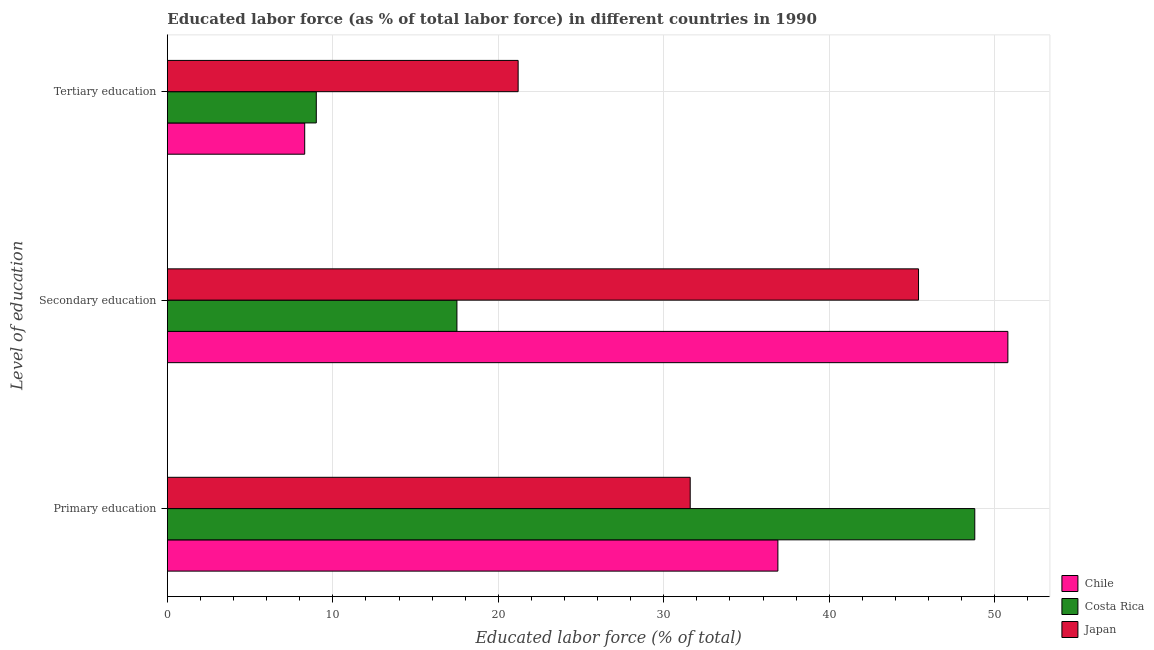How many bars are there on the 1st tick from the top?
Ensure brevity in your answer.  3. What is the percentage of labor force who received tertiary education in Japan?
Offer a terse response. 21.2. Across all countries, what is the maximum percentage of labor force who received secondary education?
Offer a very short reply. 50.8. In which country was the percentage of labor force who received primary education maximum?
Offer a terse response. Costa Rica. What is the total percentage of labor force who received secondary education in the graph?
Your answer should be very brief. 113.7. What is the difference between the percentage of labor force who received secondary education in Chile and that in Costa Rica?
Keep it short and to the point. 33.3. What is the difference between the percentage of labor force who received primary education in Chile and the percentage of labor force who received secondary education in Japan?
Ensure brevity in your answer.  -8.5. What is the average percentage of labor force who received tertiary education per country?
Provide a short and direct response. 12.83. What is the difference between the percentage of labor force who received secondary education and percentage of labor force who received primary education in Japan?
Your response must be concise. 13.8. In how many countries, is the percentage of labor force who received tertiary education greater than 44 %?
Your answer should be very brief. 0. What is the ratio of the percentage of labor force who received primary education in Chile to that in Japan?
Provide a succinct answer. 1.17. What is the difference between the highest and the second highest percentage of labor force who received tertiary education?
Your answer should be compact. 12.2. What is the difference between the highest and the lowest percentage of labor force who received primary education?
Your answer should be compact. 17.2. In how many countries, is the percentage of labor force who received tertiary education greater than the average percentage of labor force who received tertiary education taken over all countries?
Provide a short and direct response. 1. Is the sum of the percentage of labor force who received tertiary education in Costa Rica and Chile greater than the maximum percentage of labor force who received primary education across all countries?
Make the answer very short. No. What does the 3rd bar from the top in Secondary education represents?
Offer a very short reply. Chile. How many bars are there?
Your answer should be very brief. 9. Are the values on the major ticks of X-axis written in scientific E-notation?
Provide a succinct answer. No. Does the graph contain any zero values?
Make the answer very short. No. Does the graph contain grids?
Your answer should be very brief. Yes. Where does the legend appear in the graph?
Your answer should be very brief. Bottom right. What is the title of the graph?
Your answer should be very brief. Educated labor force (as % of total labor force) in different countries in 1990. Does "South Africa" appear as one of the legend labels in the graph?
Keep it short and to the point. No. What is the label or title of the X-axis?
Make the answer very short. Educated labor force (% of total). What is the label or title of the Y-axis?
Offer a terse response. Level of education. What is the Educated labor force (% of total) of Chile in Primary education?
Keep it short and to the point. 36.9. What is the Educated labor force (% of total) in Costa Rica in Primary education?
Give a very brief answer. 48.8. What is the Educated labor force (% of total) of Japan in Primary education?
Your response must be concise. 31.6. What is the Educated labor force (% of total) in Chile in Secondary education?
Provide a short and direct response. 50.8. What is the Educated labor force (% of total) in Costa Rica in Secondary education?
Ensure brevity in your answer.  17.5. What is the Educated labor force (% of total) in Japan in Secondary education?
Offer a very short reply. 45.4. What is the Educated labor force (% of total) of Chile in Tertiary education?
Make the answer very short. 8.3. What is the Educated labor force (% of total) in Costa Rica in Tertiary education?
Your response must be concise. 9. What is the Educated labor force (% of total) in Japan in Tertiary education?
Provide a short and direct response. 21.2. Across all Level of education, what is the maximum Educated labor force (% of total) in Chile?
Your answer should be compact. 50.8. Across all Level of education, what is the maximum Educated labor force (% of total) in Costa Rica?
Your response must be concise. 48.8. Across all Level of education, what is the maximum Educated labor force (% of total) of Japan?
Ensure brevity in your answer.  45.4. Across all Level of education, what is the minimum Educated labor force (% of total) of Chile?
Provide a short and direct response. 8.3. Across all Level of education, what is the minimum Educated labor force (% of total) of Costa Rica?
Your response must be concise. 9. Across all Level of education, what is the minimum Educated labor force (% of total) in Japan?
Your response must be concise. 21.2. What is the total Educated labor force (% of total) in Chile in the graph?
Ensure brevity in your answer.  96. What is the total Educated labor force (% of total) in Costa Rica in the graph?
Provide a succinct answer. 75.3. What is the total Educated labor force (% of total) of Japan in the graph?
Your answer should be compact. 98.2. What is the difference between the Educated labor force (% of total) in Chile in Primary education and that in Secondary education?
Your answer should be compact. -13.9. What is the difference between the Educated labor force (% of total) of Costa Rica in Primary education and that in Secondary education?
Your answer should be very brief. 31.3. What is the difference between the Educated labor force (% of total) of Chile in Primary education and that in Tertiary education?
Make the answer very short. 28.6. What is the difference between the Educated labor force (% of total) of Costa Rica in Primary education and that in Tertiary education?
Provide a short and direct response. 39.8. What is the difference between the Educated labor force (% of total) in Japan in Primary education and that in Tertiary education?
Keep it short and to the point. 10.4. What is the difference between the Educated labor force (% of total) of Chile in Secondary education and that in Tertiary education?
Offer a very short reply. 42.5. What is the difference between the Educated labor force (% of total) of Costa Rica in Secondary education and that in Tertiary education?
Your answer should be compact. 8.5. What is the difference between the Educated labor force (% of total) in Japan in Secondary education and that in Tertiary education?
Offer a terse response. 24.2. What is the difference between the Educated labor force (% of total) of Chile in Primary education and the Educated labor force (% of total) of Japan in Secondary education?
Provide a short and direct response. -8.5. What is the difference between the Educated labor force (% of total) in Costa Rica in Primary education and the Educated labor force (% of total) in Japan in Secondary education?
Your response must be concise. 3.4. What is the difference between the Educated labor force (% of total) in Chile in Primary education and the Educated labor force (% of total) in Costa Rica in Tertiary education?
Your response must be concise. 27.9. What is the difference between the Educated labor force (% of total) in Chile in Primary education and the Educated labor force (% of total) in Japan in Tertiary education?
Offer a terse response. 15.7. What is the difference between the Educated labor force (% of total) in Costa Rica in Primary education and the Educated labor force (% of total) in Japan in Tertiary education?
Give a very brief answer. 27.6. What is the difference between the Educated labor force (% of total) in Chile in Secondary education and the Educated labor force (% of total) in Costa Rica in Tertiary education?
Provide a short and direct response. 41.8. What is the difference between the Educated labor force (% of total) in Chile in Secondary education and the Educated labor force (% of total) in Japan in Tertiary education?
Ensure brevity in your answer.  29.6. What is the difference between the Educated labor force (% of total) in Costa Rica in Secondary education and the Educated labor force (% of total) in Japan in Tertiary education?
Your answer should be compact. -3.7. What is the average Educated labor force (% of total) of Chile per Level of education?
Give a very brief answer. 32. What is the average Educated labor force (% of total) in Costa Rica per Level of education?
Provide a succinct answer. 25.1. What is the average Educated labor force (% of total) in Japan per Level of education?
Offer a very short reply. 32.73. What is the difference between the Educated labor force (% of total) in Chile and Educated labor force (% of total) in Costa Rica in Primary education?
Your response must be concise. -11.9. What is the difference between the Educated labor force (% of total) in Chile and Educated labor force (% of total) in Costa Rica in Secondary education?
Offer a very short reply. 33.3. What is the difference between the Educated labor force (% of total) of Chile and Educated labor force (% of total) of Japan in Secondary education?
Provide a short and direct response. 5.4. What is the difference between the Educated labor force (% of total) in Costa Rica and Educated labor force (% of total) in Japan in Secondary education?
Ensure brevity in your answer.  -27.9. What is the difference between the Educated labor force (% of total) of Chile and Educated labor force (% of total) of Costa Rica in Tertiary education?
Keep it short and to the point. -0.7. What is the difference between the Educated labor force (% of total) of Chile and Educated labor force (% of total) of Japan in Tertiary education?
Give a very brief answer. -12.9. What is the difference between the Educated labor force (% of total) in Costa Rica and Educated labor force (% of total) in Japan in Tertiary education?
Your answer should be compact. -12.2. What is the ratio of the Educated labor force (% of total) of Chile in Primary education to that in Secondary education?
Provide a short and direct response. 0.73. What is the ratio of the Educated labor force (% of total) in Costa Rica in Primary education to that in Secondary education?
Provide a short and direct response. 2.79. What is the ratio of the Educated labor force (% of total) in Japan in Primary education to that in Secondary education?
Your answer should be very brief. 0.7. What is the ratio of the Educated labor force (% of total) in Chile in Primary education to that in Tertiary education?
Give a very brief answer. 4.45. What is the ratio of the Educated labor force (% of total) in Costa Rica in Primary education to that in Tertiary education?
Provide a short and direct response. 5.42. What is the ratio of the Educated labor force (% of total) in Japan in Primary education to that in Tertiary education?
Your response must be concise. 1.49. What is the ratio of the Educated labor force (% of total) of Chile in Secondary education to that in Tertiary education?
Your answer should be very brief. 6.12. What is the ratio of the Educated labor force (% of total) of Costa Rica in Secondary education to that in Tertiary education?
Provide a succinct answer. 1.94. What is the ratio of the Educated labor force (% of total) in Japan in Secondary education to that in Tertiary education?
Your response must be concise. 2.14. What is the difference between the highest and the second highest Educated labor force (% of total) in Chile?
Your answer should be compact. 13.9. What is the difference between the highest and the second highest Educated labor force (% of total) in Costa Rica?
Ensure brevity in your answer.  31.3. What is the difference between the highest and the lowest Educated labor force (% of total) of Chile?
Offer a terse response. 42.5. What is the difference between the highest and the lowest Educated labor force (% of total) in Costa Rica?
Your answer should be compact. 39.8. What is the difference between the highest and the lowest Educated labor force (% of total) of Japan?
Offer a very short reply. 24.2. 